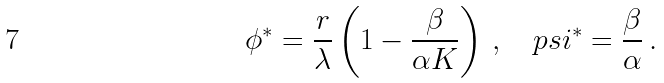<formula> <loc_0><loc_0><loc_500><loc_500>\phi ^ { * } = \frac { r } { \lambda } \left ( 1 - \frac { \beta } { \alpha K } \right ) \, , \quad p s i ^ { * } = \frac { \beta } { \alpha } \, .</formula> 